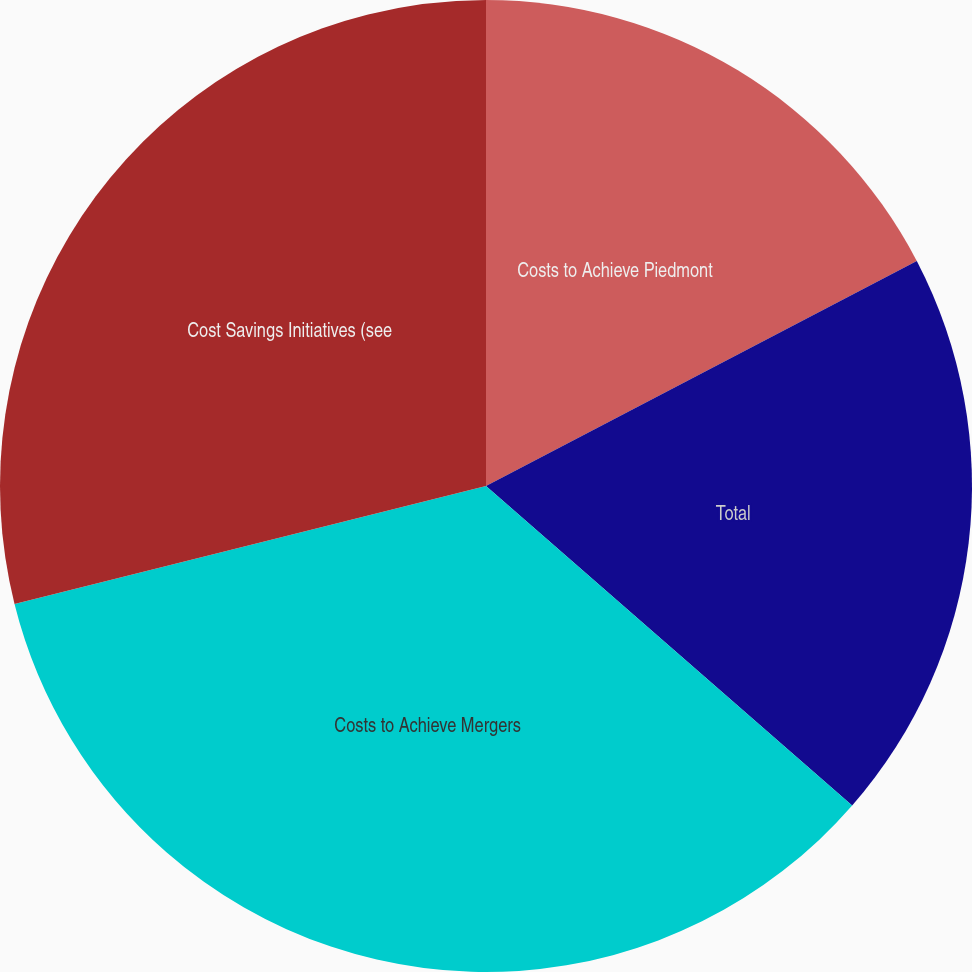<chart> <loc_0><loc_0><loc_500><loc_500><pie_chart><fcel>Costs to Achieve Piedmont<fcel>Total<fcel>Costs to Achieve Mergers<fcel>Cost Savings Initiatives (see<nl><fcel>17.34%<fcel>19.08%<fcel>34.68%<fcel>28.9%<nl></chart> 